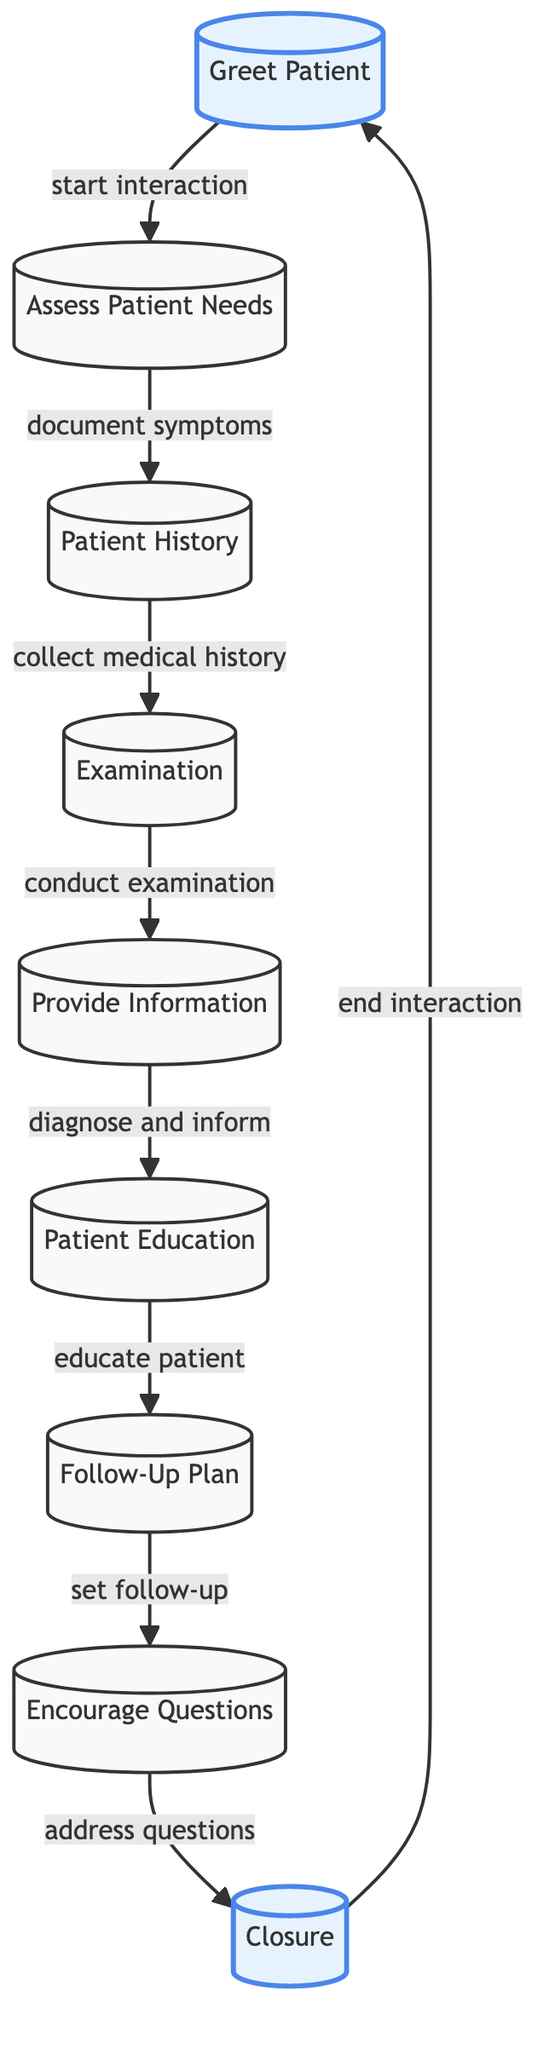What is the first step in the nurse-patient interaction? The first step shown in the diagram is "Greet Patient," which is represented as node 1. This node initiates the flow of the interaction process.
Answer: Greet Patient What follows after "Assess Patient Needs"? The diagram indicates that after "Assess Patient Needs" (node 2), the next step is "Patient History" (node 3). This relationship is shown with a directed edge between these two nodes.
Answer: Patient History How many total steps are indicated in the flowchart? By counting the nodes in the diagram, there are a total of 9 steps representing different practices in the nurse-patient interaction.
Answer: 9 What is the last step before ending the interaction? The final step before the interaction ends is "Closure," which is indicated as node 9. According to the flow, it leads back to node 1 to restart the interaction.
Answer: Closure What is the purpose of the node "Encourage Questions"? The diagram shows that "Encourage Questions" (node 8) serves as a step where the nurse addresses any queries the patient may have before closing the interaction. This is part of ensuring effective communication.
Answer: Address questions What is the relationship between "Provide Information" and "Patient Education"? The flowchart indicates that "Provide Information" (node 5) leads directly to "Patient Education" (node 6), showing that after the nurse diagnoses and informs the patient, education follows as the next key step.
Answer: Provide Information leads to Patient Education What type of node is "Greet Patient" classified as in the diagram? In the diagram, "Greet Patient" is highlighted to signify its importance as the starting point of the interaction, which classifies it as a significant node.
Answer: Highlighted What communication technique is most emphasized at the end of the interaction? The node "Closure" at the end of the interaction emphasizes summarizing and concluding the session, which is crucial for effective communication and ensures nothing is overlooked as the consultation wraps up.
Answer: Closure 